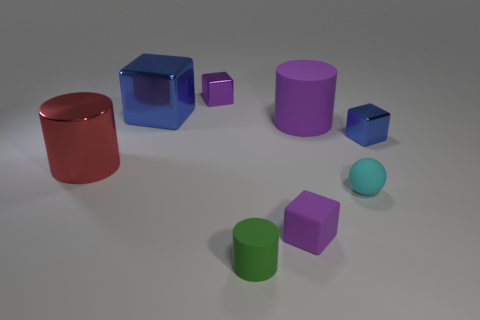Add 2 large blue rubber blocks. How many objects exist? 10 Subtract all spheres. How many objects are left? 7 Add 5 small cyan matte things. How many small cyan matte things exist? 6 Subtract 0 purple balls. How many objects are left? 8 Subtract all large yellow blocks. Subtract all red metal objects. How many objects are left? 7 Add 8 purple cylinders. How many purple cylinders are left? 9 